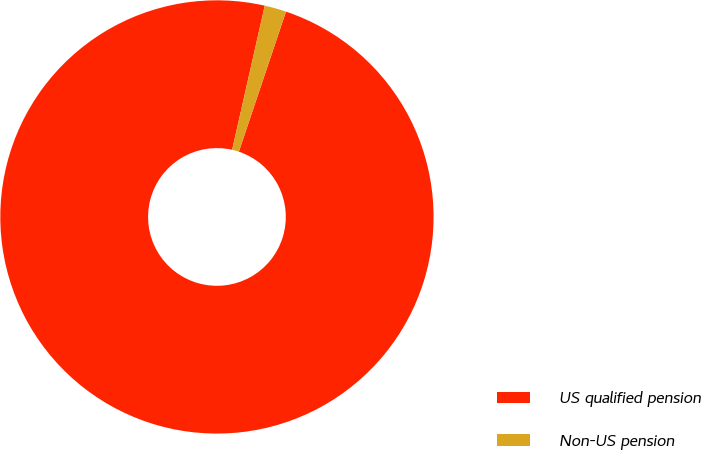<chart> <loc_0><loc_0><loc_500><loc_500><pie_chart><fcel>US qualified pension<fcel>Non-US pension<nl><fcel>98.38%<fcel>1.62%<nl></chart> 